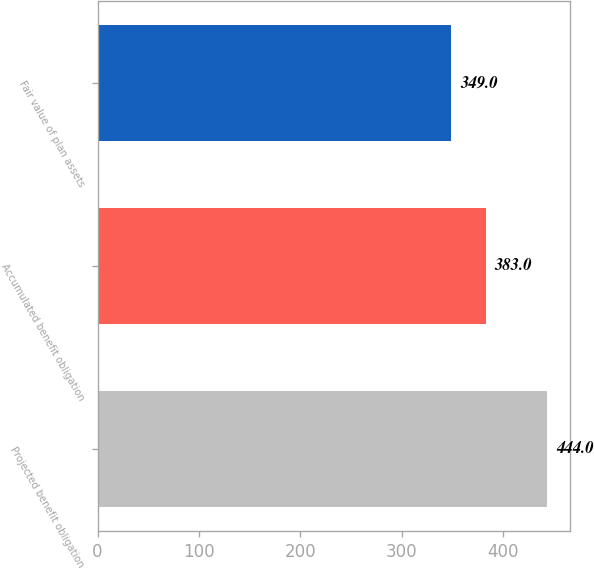Convert chart. <chart><loc_0><loc_0><loc_500><loc_500><bar_chart><fcel>Projected benefit obligation<fcel>Accumulated benefit obligation<fcel>Fair value of plan assets<nl><fcel>444<fcel>383<fcel>349<nl></chart> 